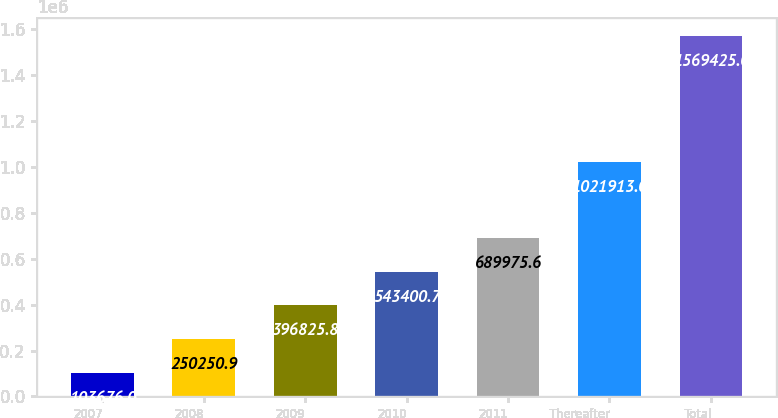Convert chart to OTSL. <chart><loc_0><loc_0><loc_500><loc_500><bar_chart><fcel>2007<fcel>2008<fcel>2009<fcel>2010<fcel>2011<fcel>Thereafter<fcel>Total<nl><fcel>103676<fcel>250251<fcel>396826<fcel>543401<fcel>689976<fcel>1.02191e+06<fcel>1.56942e+06<nl></chart> 